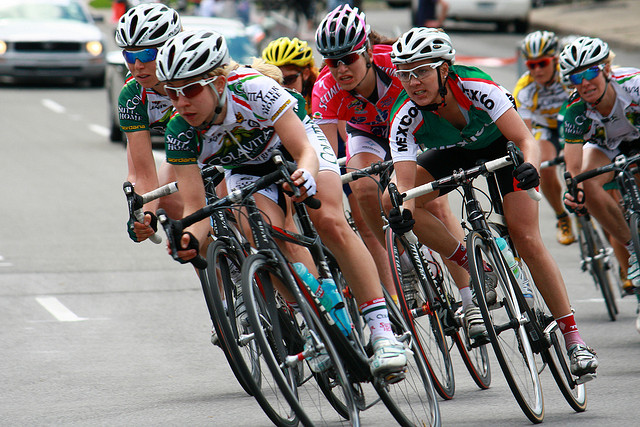Read all the text in this image. TTA ME SUIT MEXCO GO TTER COLAVIT 